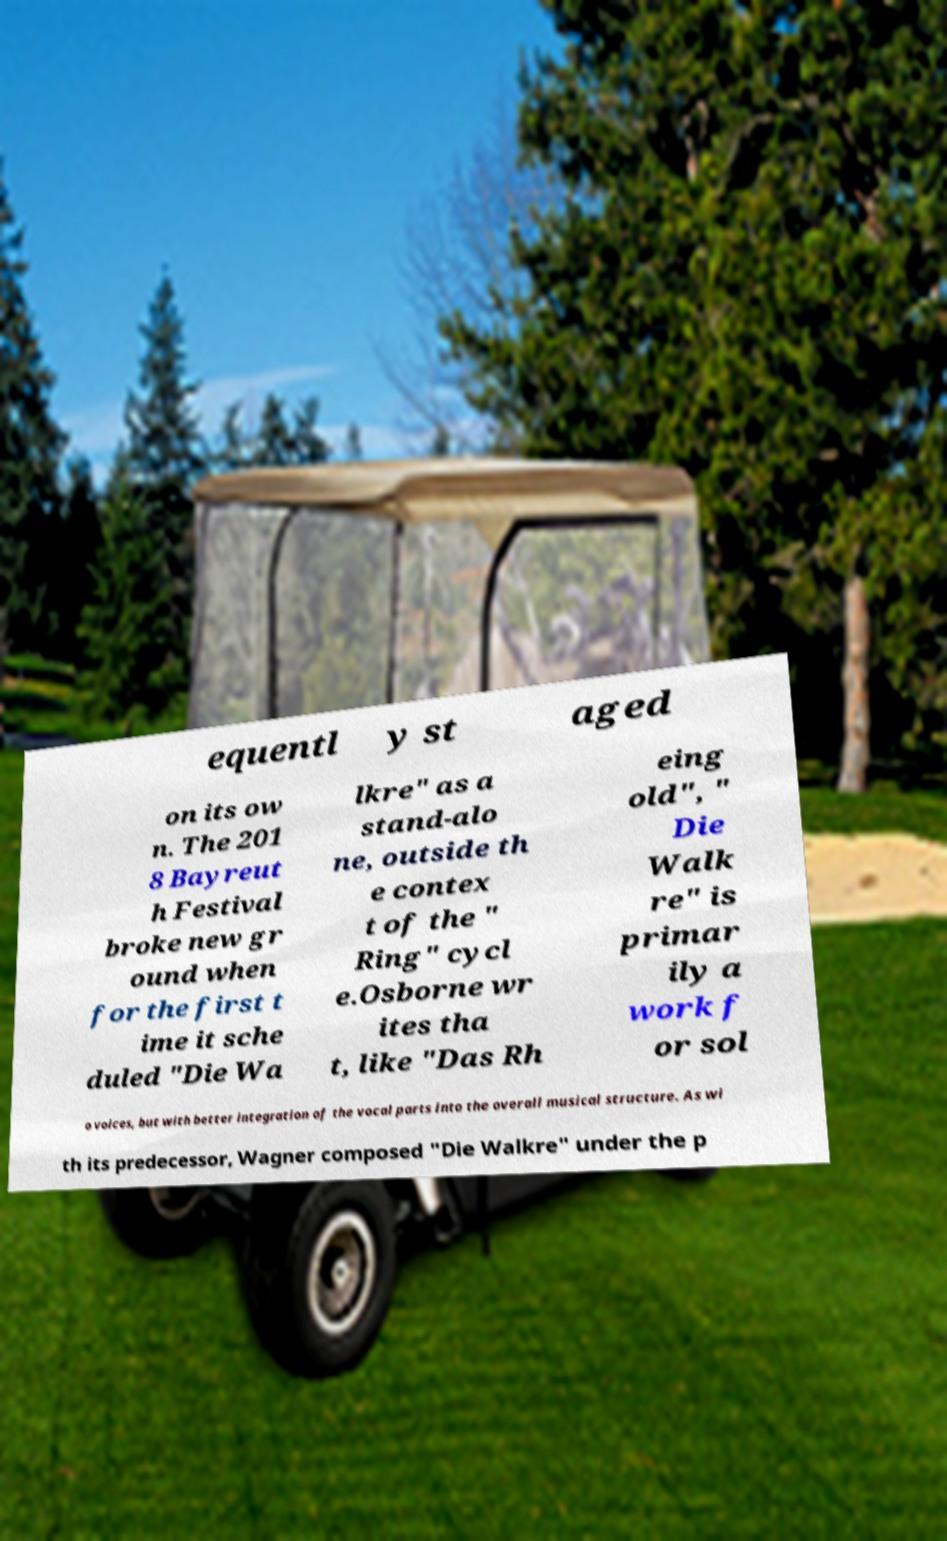Please read and relay the text visible in this image. What does it say? equentl y st aged on its ow n. The 201 8 Bayreut h Festival broke new gr ound when for the first t ime it sche duled "Die Wa lkre" as a stand-alo ne, outside th e contex t of the " Ring" cycl e.Osborne wr ites tha t, like "Das Rh eing old", " Die Walk re" is primar ily a work f or sol o voices, but with better integration of the vocal parts into the overall musical structure. As wi th its predecessor, Wagner composed "Die Walkre" under the p 